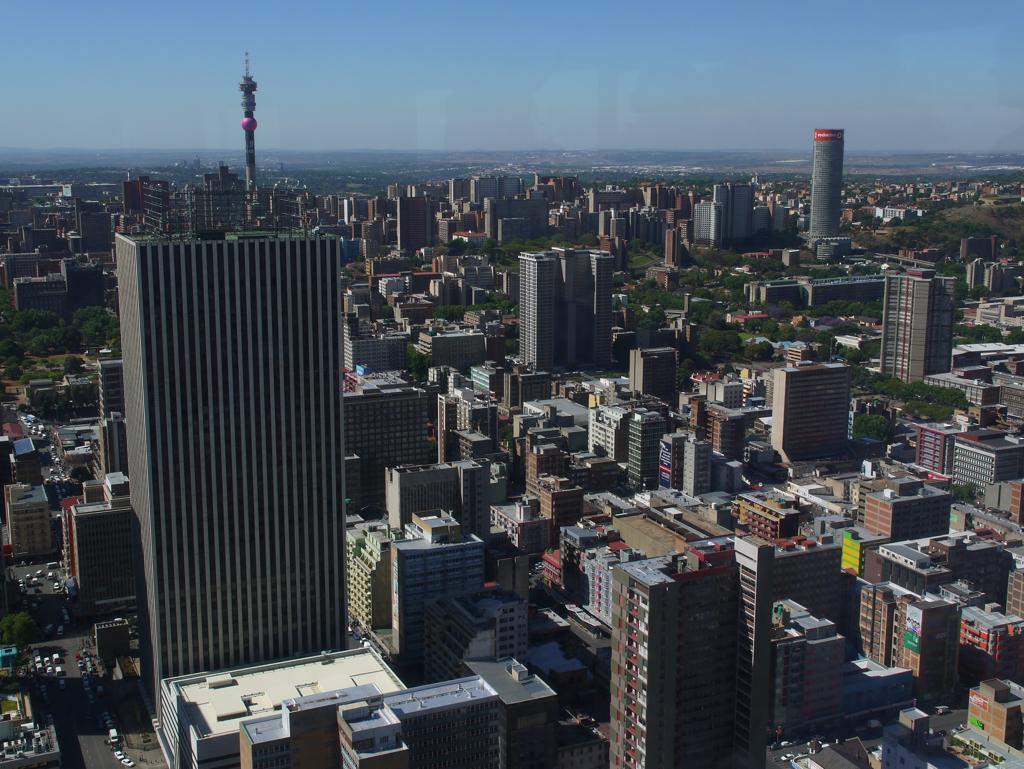Describe this image in one or two sentences. In this image we can see some buildings and there are some vehicles on the road in the bottom left of the image. There are some trees and we can see the sky at the top. 